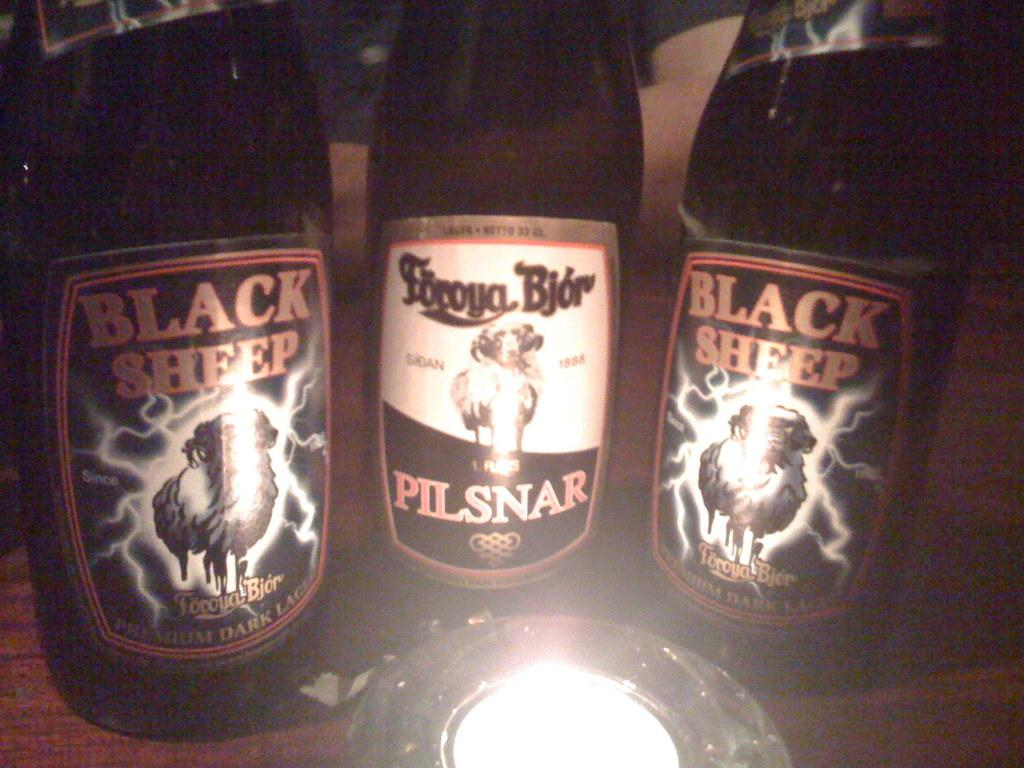<image>
Share a concise interpretation of the image provided. Bottles of Black Sheep and Foroya Bjor beers. 